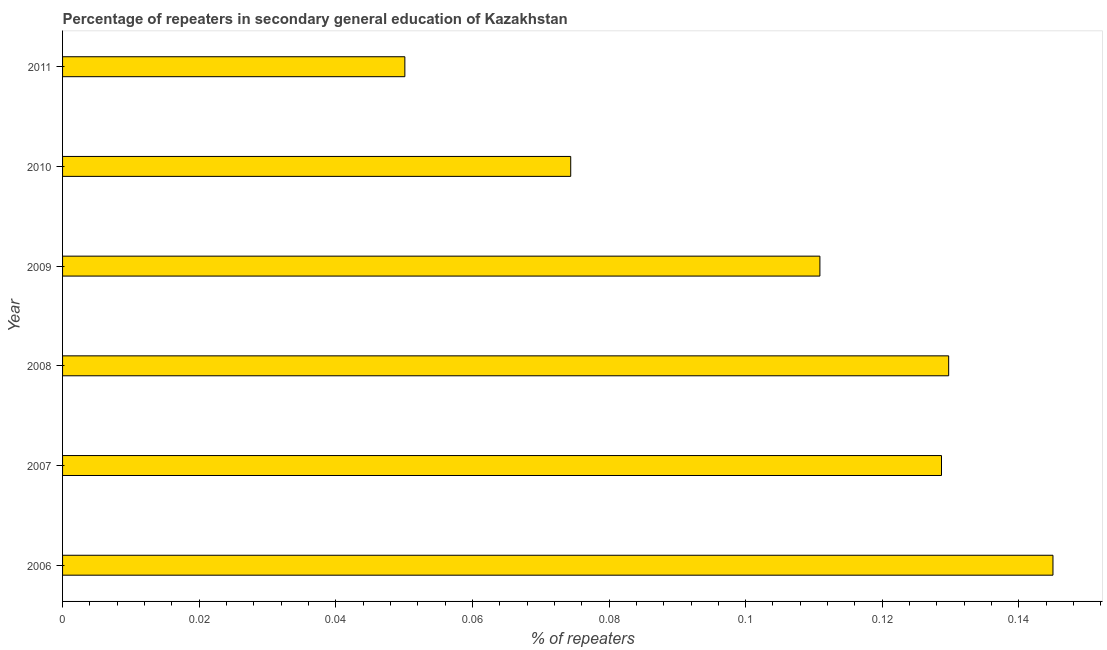Does the graph contain any zero values?
Provide a succinct answer. No. Does the graph contain grids?
Provide a succinct answer. No. What is the title of the graph?
Give a very brief answer. Percentage of repeaters in secondary general education of Kazakhstan. What is the label or title of the X-axis?
Your answer should be very brief. % of repeaters. What is the label or title of the Y-axis?
Your answer should be very brief. Year. What is the percentage of repeaters in 2010?
Provide a succinct answer. 0.07. Across all years, what is the maximum percentage of repeaters?
Ensure brevity in your answer.  0.14. Across all years, what is the minimum percentage of repeaters?
Ensure brevity in your answer.  0.05. In which year was the percentage of repeaters minimum?
Your answer should be compact. 2011. What is the sum of the percentage of repeaters?
Ensure brevity in your answer.  0.64. What is the difference between the percentage of repeaters in 2006 and 2008?
Give a very brief answer. 0.01. What is the average percentage of repeaters per year?
Your answer should be compact. 0.11. What is the median percentage of repeaters?
Provide a succinct answer. 0.12. What is the ratio of the percentage of repeaters in 2007 to that in 2010?
Offer a very short reply. 1.73. Is the percentage of repeaters in 2008 less than that in 2011?
Keep it short and to the point. No. What is the difference between the highest and the second highest percentage of repeaters?
Ensure brevity in your answer.  0.01. What is the difference between the highest and the lowest percentage of repeaters?
Provide a short and direct response. 0.09. In how many years, is the percentage of repeaters greater than the average percentage of repeaters taken over all years?
Offer a terse response. 4. How many bars are there?
Your answer should be very brief. 6. Are all the bars in the graph horizontal?
Give a very brief answer. Yes. How many years are there in the graph?
Ensure brevity in your answer.  6. What is the difference between two consecutive major ticks on the X-axis?
Ensure brevity in your answer.  0.02. Are the values on the major ticks of X-axis written in scientific E-notation?
Provide a succinct answer. No. What is the % of repeaters in 2006?
Your response must be concise. 0.14. What is the % of repeaters in 2007?
Give a very brief answer. 0.13. What is the % of repeaters in 2008?
Make the answer very short. 0.13. What is the % of repeaters of 2009?
Offer a terse response. 0.11. What is the % of repeaters in 2010?
Provide a short and direct response. 0.07. What is the % of repeaters of 2011?
Keep it short and to the point. 0.05. What is the difference between the % of repeaters in 2006 and 2007?
Keep it short and to the point. 0.02. What is the difference between the % of repeaters in 2006 and 2008?
Provide a succinct answer. 0.02. What is the difference between the % of repeaters in 2006 and 2009?
Give a very brief answer. 0.03. What is the difference between the % of repeaters in 2006 and 2010?
Keep it short and to the point. 0.07. What is the difference between the % of repeaters in 2006 and 2011?
Offer a very short reply. 0.09. What is the difference between the % of repeaters in 2007 and 2008?
Keep it short and to the point. -0. What is the difference between the % of repeaters in 2007 and 2009?
Your response must be concise. 0.02. What is the difference between the % of repeaters in 2007 and 2010?
Your answer should be very brief. 0.05. What is the difference between the % of repeaters in 2007 and 2011?
Ensure brevity in your answer.  0.08. What is the difference between the % of repeaters in 2008 and 2009?
Give a very brief answer. 0.02. What is the difference between the % of repeaters in 2008 and 2010?
Provide a short and direct response. 0.06. What is the difference between the % of repeaters in 2008 and 2011?
Your response must be concise. 0.08. What is the difference between the % of repeaters in 2009 and 2010?
Give a very brief answer. 0.04. What is the difference between the % of repeaters in 2009 and 2011?
Your answer should be compact. 0.06. What is the difference between the % of repeaters in 2010 and 2011?
Offer a very short reply. 0.02. What is the ratio of the % of repeaters in 2006 to that in 2007?
Your response must be concise. 1.13. What is the ratio of the % of repeaters in 2006 to that in 2008?
Make the answer very short. 1.12. What is the ratio of the % of repeaters in 2006 to that in 2009?
Provide a short and direct response. 1.31. What is the ratio of the % of repeaters in 2006 to that in 2010?
Make the answer very short. 1.95. What is the ratio of the % of repeaters in 2006 to that in 2011?
Provide a short and direct response. 2.89. What is the ratio of the % of repeaters in 2007 to that in 2009?
Give a very brief answer. 1.16. What is the ratio of the % of repeaters in 2007 to that in 2010?
Ensure brevity in your answer.  1.73. What is the ratio of the % of repeaters in 2007 to that in 2011?
Provide a succinct answer. 2.57. What is the ratio of the % of repeaters in 2008 to that in 2009?
Give a very brief answer. 1.17. What is the ratio of the % of repeaters in 2008 to that in 2010?
Provide a succinct answer. 1.74. What is the ratio of the % of repeaters in 2008 to that in 2011?
Make the answer very short. 2.59. What is the ratio of the % of repeaters in 2009 to that in 2010?
Ensure brevity in your answer.  1.49. What is the ratio of the % of repeaters in 2009 to that in 2011?
Give a very brief answer. 2.21. What is the ratio of the % of repeaters in 2010 to that in 2011?
Your response must be concise. 1.49. 